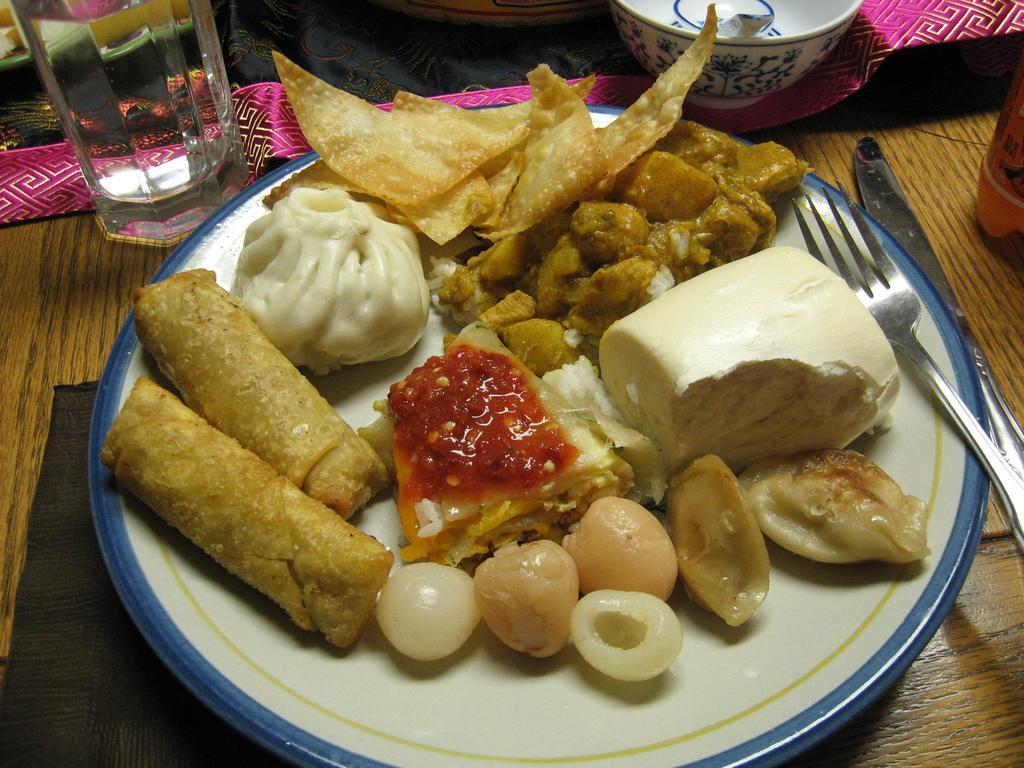How would you summarize this image in a sentence or two? In this image there are some food items are kept in a plate at bottom of this image and there is a fork spoons at right side of this image and the plate is kept on a table and there is a glass at top left corner of this image and there is a bowl at top of this image. 